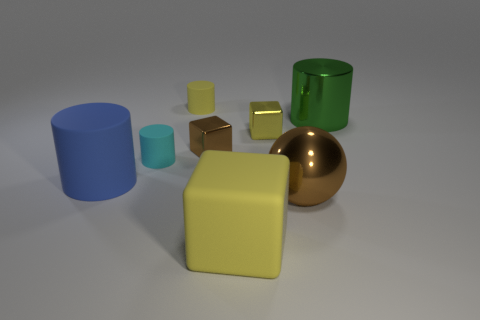Add 2 large metallic spheres. How many objects exist? 10 Subtract all blocks. How many objects are left? 5 Subtract all big things. Subtract all tiny purple shiny cubes. How many objects are left? 4 Add 1 large things. How many large things are left? 5 Add 1 big yellow matte blocks. How many big yellow matte blocks exist? 2 Subtract 0 cyan balls. How many objects are left? 8 